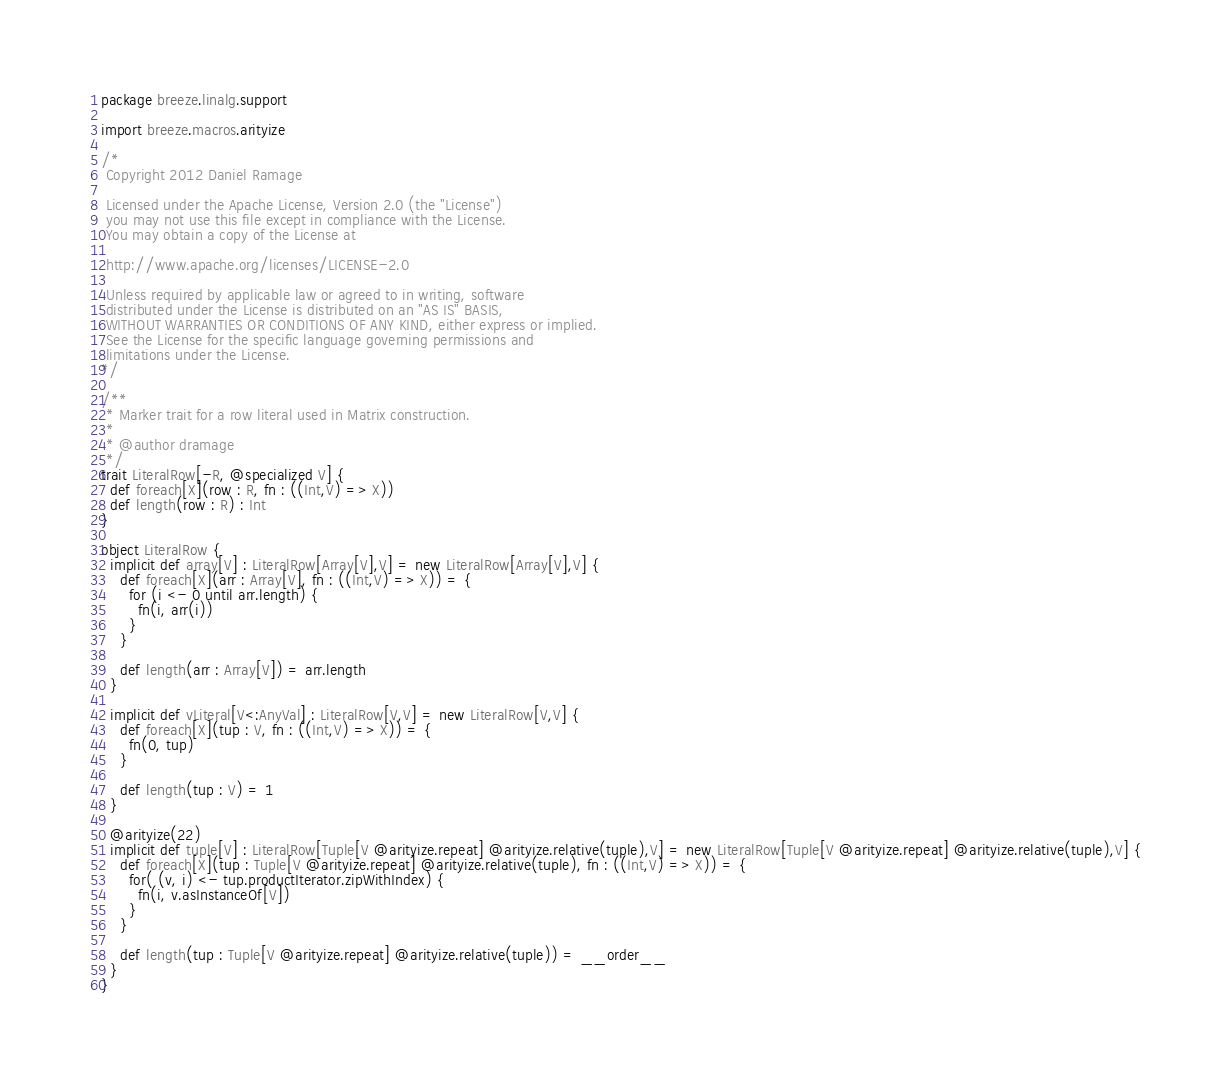<code> <loc_0><loc_0><loc_500><loc_500><_Scala_>package breeze.linalg.support

import breeze.macros.arityize

/*
 Copyright 2012 Daniel Ramage

 Licensed under the Apache License, Version 2.0 (the "License")
 you may not use this file except in compliance with the License.
 You may obtain a copy of the License at

 http://www.apache.org/licenses/LICENSE-2.0

 Unless required by applicable law or agreed to in writing, software
 distributed under the License is distributed on an "AS IS" BASIS,
 WITHOUT WARRANTIES OR CONDITIONS OF ANY KIND, either express or implied.
 See the License for the specific language governing permissions and
 limitations under the License.
*/

/**
 * Marker trait for a row literal used in Matrix construction.
 *
 * @author dramage
 */
trait LiteralRow[-R, @specialized V] {
  def foreach[X](row : R, fn : ((Int,V) => X))
  def length(row : R) : Int
}

object LiteralRow {
  implicit def array[V] : LiteralRow[Array[V],V] = new LiteralRow[Array[V],V] {
    def foreach[X](arr : Array[V], fn : ((Int,V) => X)) = {
      for (i <- 0 until arr.length) {
        fn(i, arr(i))
      }
    }

    def length(arr : Array[V]) = arr.length
  }

  implicit def vLiteral[V<:AnyVal] : LiteralRow[V,V] = new LiteralRow[V,V] {
    def foreach[X](tup : V, fn : ((Int,V) => X)) = {
      fn(0, tup)
    }

    def length(tup : V) = 1
  }

  @arityize(22)
  implicit def tuple[V] : LiteralRow[Tuple[V @arityize.repeat] @arityize.relative(tuple),V] = new LiteralRow[Tuple[V @arityize.repeat] @arityize.relative(tuple),V] {
    def foreach[X](tup : Tuple[V @arityize.repeat] @arityize.relative(tuple), fn : ((Int,V) => X)) = {
      for( (v, i) <- tup.productIterator.zipWithIndex) {
        fn(i, v.asInstanceOf[V])
      }
    }

    def length(tup : Tuple[V @arityize.repeat] @arityize.relative(tuple)) = __order__
  }
}
</code> 